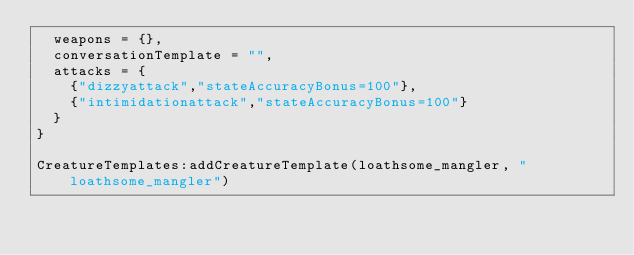Convert code to text. <code><loc_0><loc_0><loc_500><loc_500><_Lua_>	weapons = {},
	conversationTemplate = "",
	attacks = {
		{"dizzyattack","stateAccuracyBonus=100"},
		{"intimidationattack","stateAccuracyBonus=100"}
	}
}

CreatureTemplates:addCreatureTemplate(loathsome_mangler, "loathsome_mangler")
</code> 